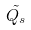<formula> <loc_0><loc_0><loc_500><loc_500>\tilde { Q _ { s } }</formula> 